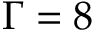<formula> <loc_0><loc_0><loc_500><loc_500>\Gamma = 8</formula> 